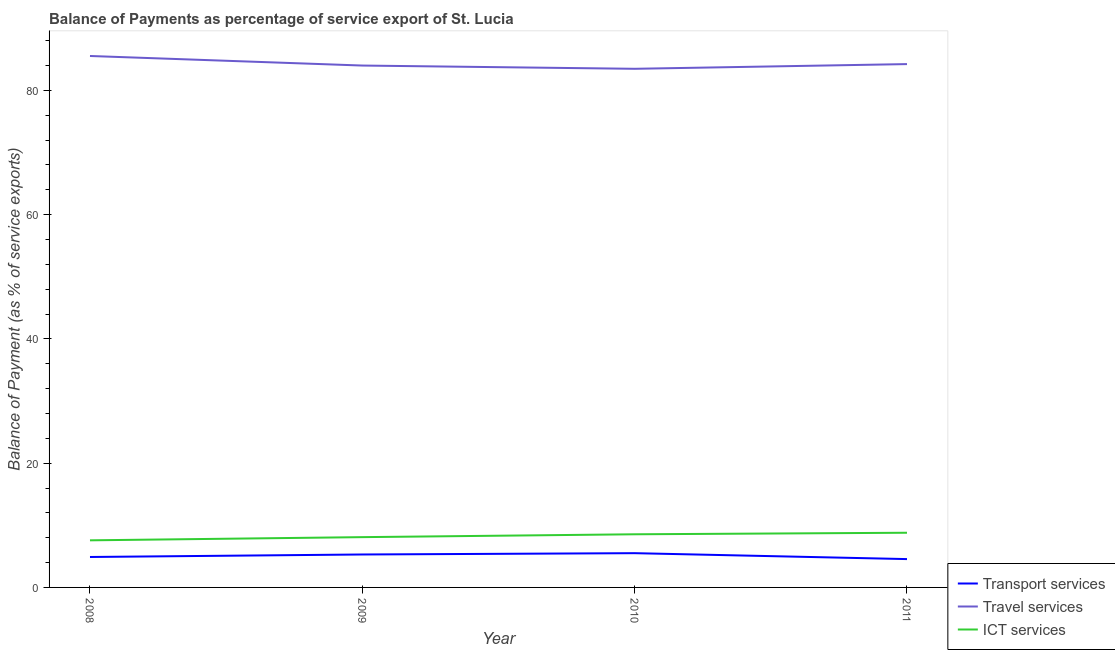How many different coloured lines are there?
Ensure brevity in your answer.  3. Does the line corresponding to balance of payment of travel services intersect with the line corresponding to balance of payment of transport services?
Your response must be concise. No. What is the balance of payment of transport services in 2010?
Provide a short and direct response. 5.51. Across all years, what is the maximum balance of payment of transport services?
Ensure brevity in your answer.  5.51. Across all years, what is the minimum balance of payment of ict services?
Give a very brief answer. 7.58. In which year was the balance of payment of ict services maximum?
Provide a succinct answer. 2011. What is the total balance of payment of transport services in the graph?
Your response must be concise. 20.27. What is the difference between the balance of payment of travel services in 2008 and that in 2011?
Give a very brief answer. 1.3. What is the difference between the balance of payment of transport services in 2010 and the balance of payment of ict services in 2008?
Your answer should be compact. -2.07. What is the average balance of payment of travel services per year?
Make the answer very short. 84.31. In the year 2010, what is the difference between the balance of payment of ict services and balance of payment of travel services?
Ensure brevity in your answer.  -74.92. What is the ratio of the balance of payment of travel services in 2008 to that in 2010?
Give a very brief answer. 1.02. Is the difference between the balance of payment of travel services in 2008 and 2011 greater than the difference between the balance of payment of ict services in 2008 and 2011?
Your answer should be very brief. Yes. What is the difference between the highest and the second highest balance of payment of ict services?
Offer a terse response. 0.25. What is the difference between the highest and the lowest balance of payment of transport services?
Provide a short and direct response. 0.95. In how many years, is the balance of payment of ict services greater than the average balance of payment of ict services taken over all years?
Offer a very short reply. 2. Is the sum of the balance of payment of travel services in 2009 and 2010 greater than the maximum balance of payment of transport services across all years?
Keep it short and to the point. Yes. Does the balance of payment of ict services monotonically increase over the years?
Ensure brevity in your answer.  Yes. Is the balance of payment of ict services strictly less than the balance of payment of travel services over the years?
Provide a short and direct response. Yes. How many years are there in the graph?
Offer a very short reply. 4. Are the values on the major ticks of Y-axis written in scientific E-notation?
Provide a succinct answer. No. Does the graph contain grids?
Your response must be concise. No. What is the title of the graph?
Provide a succinct answer. Balance of Payments as percentage of service export of St. Lucia. What is the label or title of the Y-axis?
Your answer should be compact. Balance of Payment (as % of service exports). What is the Balance of Payment (as % of service exports) in Transport services in 2008?
Provide a short and direct response. 4.9. What is the Balance of Payment (as % of service exports) of Travel services in 2008?
Ensure brevity in your answer.  85.54. What is the Balance of Payment (as % of service exports) of ICT services in 2008?
Your answer should be compact. 7.58. What is the Balance of Payment (as % of service exports) in Transport services in 2009?
Your answer should be compact. 5.3. What is the Balance of Payment (as % of service exports) of Travel services in 2009?
Ensure brevity in your answer.  84. What is the Balance of Payment (as % of service exports) of ICT services in 2009?
Offer a terse response. 8.09. What is the Balance of Payment (as % of service exports) in Transport services in 2010?
Give a very brief answer. 5.51. What is the Balance of Payment (as % of service exports) of Travel services in 2010?
Offer a very short reply. 83.47. What is the Balance of Payment (as % of service exports) in ICT services in 2010?
Ensure brevity in your answer.  8.55. What is the Balance of Payment (as % of service exports) of Transport services in 2011?
Make the answer very short. 4.56. What is the Balance of Payment (as % of service exports) in Travel services in 2011?
Provide a succinct answer. 84.23. What is the Balance of Payment (as % of service exports) of ICT services in 2011?
Ensure brevity in your answer.  8.8. Across all years, what is the maximum Balance of Payment (as % of service exports) in Transport services?
Give a very brief answer. 5.51. Across all years, what is the maximum Balance of Payment (as % of service exports) in Travel services?
Offer a terse response. 85.54. Across all years, what is the maximum Balance of Payment (as % of service exports) in ICT services?
Offer a terse response. 8.8. Across all years, what is the minimum Balance of Payment (as % of service exports) of Transport services?
Keep it short and to the point. 4.56. Across all years, what is the minimum Balance of Payment (as % of service exports) of Travel services?
Provide a succinct answer. 83.47. Across all years, what is the minimum Balance of Payment (as % of service exports) in ICT services?
Your response must be concise. 7.58. What is the total Balance of Payment (as % of service exports) of Transport services in the graph?
Make the answer very short. 20.27. What is the total Balance of Payment (as % of service exports) of Travel services in the graph?
Your answer should be very brief. 337.23. What is the total Balance of Payment (as % of service exports) in ICT services in the graph?
Offer a terse response. 33.03. What is the difference between the Balance of Payment (as % of service exports) of Transport services in 2008 and that in 2009?
Offer a very short reply. -0.4. What is the difference between the Balance of Payment (as % of service exports) of Travel services in 2008 and that in 2009?
Offer a terse response. 1.54. What is the difference between the Balance of Payment (as % of service exports) of ICT services in 2008 and that in 2009?
Offer a very short reply. -0.51. What is the difference between the Balance of Payment (as % of service exports) in Transport services in 2008 and that in 2010?
Offer a very short reply. -0.61. What is the difference between the Balance of Payment (as % of service exports) in Travel services in 2008 and that in 2010?
Offer a terse response. 2.06. What is the difference between the Balance of Payment (as % of service exports) in ICT services in 2008 and that in 2010?
Your answer should be very brief. -0.97. What is the difference between the Balance of Payment (as % of service exports) in Transport services in 2008 and that in 2011?
Your response must be concise. 0.34. What is the difference between the Balance of Payment (as % of service exports) of Travel services in 2008 and that in 2011?
Provide a succinct answer. 1.3. What is the difference between the Balance of Payment (as % of service exports) in ICT services in 2008 and that in 2011?
Ensure brevity in your answer.  -1.22. What is the difference between the Balance of Payment (as % of service exports) of Transport services in 2009 and that in 2010?
Your answer should be compact. -0.21. What is the difference between the Balance of Payment (as % of service exports) of Travel services in 2009 and that in 2010?
Keep it short and to the point. 0.52. What is the difference between the Balance of Payment (as % of service exports) in ICT services in 2009 and that in 2010?
Offer a very short reply. -0.46. What is the difference between the Balance of Payment (as % of service exports) in Transport services in 2009 and that in 2011?
Your response must be concise. 0.74. What is the difference between the Balance of Payment (as % of service exports) in Travel services in 2009 and that in 2011?
Ensure brevity in your answer.  -0.24. What is the difference between the Balance of Payment (as % of service exports) of ICT services in 2009 and that in 2011?
Give a very brief answer. -0.71. What is the difference between the Balance of Payment (as % of service exports) of Transport services in 2010 and that in 2011?
Your answer should be compact. 0.95. What is the difference between the Balance of Payment (as % of service exports) in Travel services in 2010 and that in 2011?
Your answer should be very brief. -0.76. What is the difference between the Balance of Payment (as % of service exports) of ICT services in 2010 and that in 2011?
Provide a succinct answer. -0.25. What is the difference between the Balance of Payment (as % of service exports) in Transport services in 2008 and the Balance of Payment (as % of service exports) in Travel services in 2009?
Offer a terse response. -79.1. What is the difference between the Balance of Payment (as % of service exports) in Transport services in 2008 and the Balance of Payment (as % of service exports) in ICT services in 2009?
Give a very brief answer. -3.19. What is the difference between the Balance of Payment (as % of service exports) in Travel services in 2008 and the Balance of Payment (as % of service exports) in ICT services in 2009?
Your answer should be very brief. 77.44. What is the difference between the Balance of Payment (as % of service exports) in Transport services in 2008 and the Balance of Payment (as % of service exports) in Travel services in 2010?
Provide a short and direct response. -78.57. What is the difference between the Balance of Payment (as % of service exports) in Transport services in 2008 and the Balance of Payment (as % of service exports) in ICT services in 2010?
Keep it short and to the point. -3.65. What is the difference between the Balance of Payment (as % of service exports) of Travel services in 2008 and the Balance of Payment (as % of service exports) of ICT services in 2010?
Ensure brevity in your answer.  76.98. What is the difference between the Balance of Payment (as % of service exports) in Transport services in 2008 and the Balance of Payment (as % of service exports) in Travel services in 2011?
Your answer should be compact. -79.33. What is the difference between the Balance of Payment (as % of service exports) of Transport services in 2008 and the Balance of Payment (as % of service exports) of ICT services in 2011?
Your response must be concise. -3.9. What is the difference between the Balance of Payment (as % of service exports) of Travel services in 2008 and the Balance of Payment (as % of service exports) of ICT services in 2011?
Ensure brevity in your answer.  76.74. What is the difference between the Balance of Payment (as % of service exports) of Transport services in 2009 and the Balance of Payment (as % of service exports) of Travel services in 2010?
Keep it short and to the point. -78.17. What is the difference between the Balance of Payment (as % of service exports) in Transport services in 2009 and the Balance of Payment (as % of service exports) in ICT services in 2010?
Provide a succinct answer. -3.25. What is the difference between the Balance of Payment (as % of service exports) in Travel services in 2009 and the Balance of Payment (as % of service exports) in ICT services in 2010?
Make the answer very short. 75.44. What is the difference between the Balance of Payment (as % of service exports) of Transport services in 2009 and the Balance of Payment (as % of service exports) of Travel services in 2011?
Ensure brevity in your answer.  -78.93. What is the difference between the Balance of Payment (as % of service exports) of Transport services in 2009 and the Balance of Payment (as % of service exports) of ICT services in 2011?
Provide a succinct answer. -3.5. What is the difference between the Balance of Payment (as % of service exports) of Travel services in 2009 and the Balance of Payment (as % of service exports) of ICT services in 2011?
Your answer should be very brief. 75.2. What is the difference between the Balance of Payment (as % of service exports) in Transport services in 2010 and the Balance of Payment (as % of service exports) in Travel services in 2011?
Offer a terse response. -78.72. What is the difference between the Balance of Payment (as % of service exports) in Transport services in 2010 and the Balance of Payment (as % of service exports) in ICT services in 2011?
Your answer should be very brief. -3.29. What is the difference between the Balance of Payment (as % of service exports) in Travel services in 2010 and the Balance of Payment (as % of service exports) in ICT services in 2011?
Your answer should be very brief. 74.67. What is the average Balance of Payment (as % of service exports) in Transport services per year?
Your answer should be compact. 5.07. What is the average Balance of Payment (as % of service exports) in Travel services per year?
Your answer should be compact. 84.31. What is the average Balance of Payment (as % of service exports) of ICT services per year?
Your answer should be compact. 8.26. In the year 2008, what is the difference between the Balance of Payment (as % of service exports) in Transport services and Balance of Payment (as % of service exports) in Travel services?
Provide a succinct answer. -80.64. In the year 2008, what is the difference between the Balance of Payment (as % of service exports) in Transport services and Balance of Payment (as % of service exports) in ICT services?
Provide a succinct answer. -2.68. In the year 2008, what is the difference between the Balance of Payment (as % of service exports) in Travel services and Balance of Payment (as % of service exports) in ICT services?
Offer a very short reply. 77.95. In the year 2009, what is the difference between the Balance of Payment (as % of service exports) in Transport services and Balance of Payment (as % of service exports) in Travel services?
Keep it short and to the point. -78.69. In the year 2009, what is the difference between the Balance of Payment (as % of service exports) of Transport services and Balance of Payment (as % of service exports) of ICT services?
Keep it short and to the point. -2.79. In the year 2009, what is the difference between the Balance of Payment (as % of service exports) of Travel services and Balance of Payment (as % of service exports) of ICT services?
Your answer should be compact. 75.9. In the year 2010, what is the difference between the Balance of Payment (as % of service exports) in Transport services and Balance of Payment (as % of service exports) in Travel services?
Your answer should be very brief. -77.96. In the year 2010, what is the difference between the Balance of Payment (as % of service exports) in Transport services and Balance of Payment (as % of service exports) in ICT services?
Your answer should be very brief. -3.04. In the year 2010, what is the difference between the Balance of Payment (as % of service exports) of Travel services and Balance of Payment (as % of service exports) of ICT services?
Offer a terse response. 74.92. In the year 2011, what is the difference between the Balance of Payment (as % of service exports) in Transport services and Balance of Payment (as % of service exports) in Travel services?
Keep it short and to the point. -79.67. In the year 2011, what is the difference between the Balance of Payment (as % of service exports) in Transport services and Balance of Payment (as % of service exports) in ICT services?
Make the answer very short. -4.24. In the year 2011, what is the difference between the Balance of Payment (as % of service exports) in Travel services and Balance of Payment (as % of service exports) in ICT services?
Give a very brief answer. 75.43. What is the ratio of the Balance of Payment (as % of service exports) of Transport services in 2008 to that in 2009?
Offer a very short reply. 0.92. What is the ratio of the Balance of Payment (as % of service exports) of Travel services in 2008 to that in 2009?
Keep it short and to the point. 1.02. What is the ratio of the Balance of Payment (as % of service exports) in ICT services in 2008 to that in 2009?
Provide a succinct answer. 0.94. What is the ratio of the Balance of Payment (as % of service exports) in Transport services in 2008 to that in 2010?
Make the answer very short. 0.89. What is the ratio of the Balance of Payment (as % of service exports) in Travel services in 2008 to that in 2010?
Make the answer very short. 1.02. What is the ratio of the Balance of Payment (as % of service exports) of ICT services in 2008 to that in 2010?
Provide a succinct answer. 0.89. What is the ratio of the Balance of Payment (as % of service exports) in Transport services in 2008 to that in 2011?
Your answer should be compact. 1.07. What is the ratio of the Balance of Payment (as % of service exports) in Travel services in 2008 to that in 2011?
Make the answer very short. 1.02. What is the ratio of the Balance of Payment (as % of service exports) in ICT services in 2008 to that in 2011?
Keep it short and to the point. 0.86. What is the ratio of the Balance of Payment (as % of service exports) of Transport services in 2009 to that in 2010?
Provide a short and direct response. 0.96. What is the ratio of the Balance of Payment (as % of service exports) of ICT services in 2009 to that in 2010?
Your answer should be very brief. 0.95. What is the ratio of the Balance of Payment (as % of service exports) of Transport services in 2009 to that in 2011?
Give a very brief answer. 1.16. What is the ratio of the Balance of Payment (as % of service exports) in ICT services in 2009 to that in 2011?
Offer a very short reply. 0.92. What is the ratio of the Balance of Payment (as % of service exports) in Transport services in 2010 to that in 2011?
Your answer should be very brief. 1.21. What is the difference between the highest and the second highest Balance of Payment (as % of service exports) in Transport services?
Ensure brevity in your answer.  0.21. What is the difference between the highest and the second highest Balance of Payment (as % of service exports) of Travel services?
Offer a terse response. 1.3. What is the difference between the highest and the second highest Balance of Payment (as % of service exports) in ICT services?
Provide a short and direct response. 0.25. What is the difference between the highest and the lowest Balance of Payment (as % of service exports) of Transport services?
Ensure brevity in your answer.  0.95. What is the difference between the highest and the lowest Balance of Payment (as % of service exports) in Travel services?
Ensure brevity in your answer.  2.06. What is the difference between the highest and the lowest Balance of Payment (as % of service exports) in ICT services?
Your response must be concise. 1.22. 